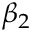Convert formula to latex. <formula><loc_0><loc_0><loc_500><loc_500>\beta _ { 2 }</formula> 